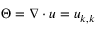<formula> <loc_0><loc_0><loc_500><loc_500>\Theta = \nabla \cdot u = u _ { k , k }</formula> 